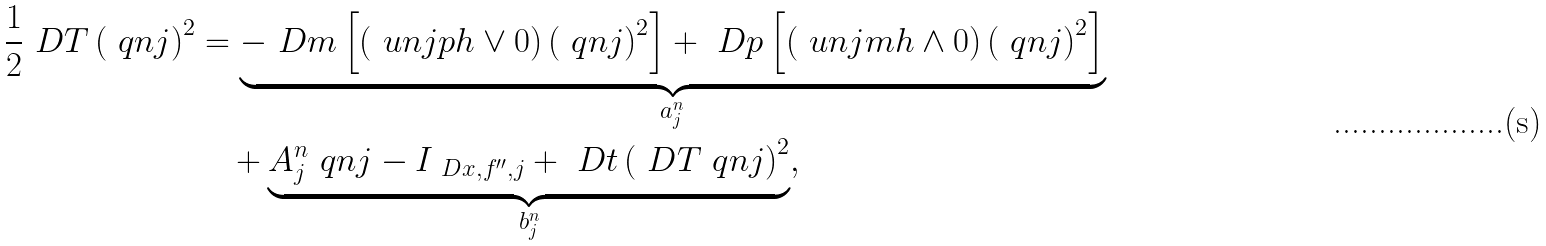Convert formula to latex. <formula><loc_0><loc_0><loc_500><loc_500>\frac { 1 } { 2 } \ D T \left ( \ q n j \right ) ^ { 2 } & = \underbrace { - \ D m \left [ \left ( \ u n j p h \vee 0 \right ) \left ( \ q n j \right ) ^ { 2 } \right ] + \ D p \left [ \left ( \ u n j m h \wedge 0 \right ) \left ( \ q n j \right ) ^ { 2 } \right ] } _ { a ^ { n } _ { j } } \\ & \quad + \underbrace { A ^ { n } _ { j } \ q n j - I _ { \ D x , f ^ { \prime \prime } , j } + \ D t \left ( \ D T \ q n j \right ) ^ { 2 } } _ { b ^ { n } _ { j } } ,</formula> 